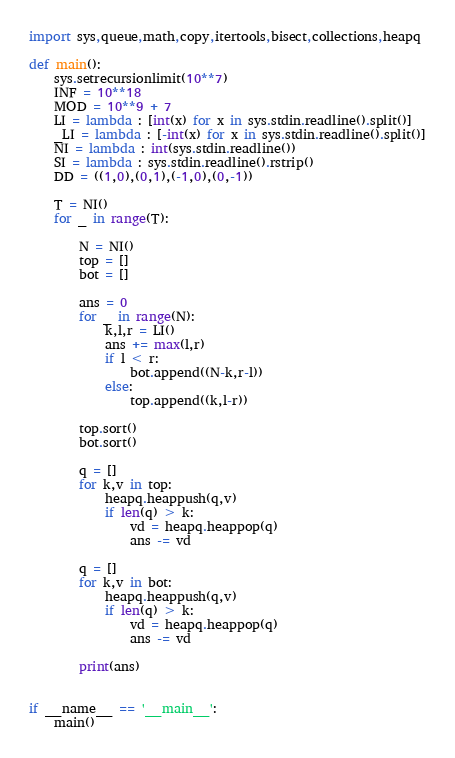<code> <loc_0><loc_0><loc_500><loc_500><_Python_>import sys,queue,math,copy,itertools,bisect,collections,heapq

def main():
    sys.setrecursionlimit(10**7)
    INF = 10**18
    MOD = 10**9 + 7
    LI = lambda : [int(x) for x in sys.stdin.readline().split()]
    _LI = lambda : [-int(x) for x in sys.stdin.readline().split()]
    NI = lambda : int(sys.stdin.readline())
    SI = lambda : sys.stdin.readline().rstrip()
    DD = ((1,0),(0,1),(-1,0),(0,-1))

    T = NI()
    for _ in range(T):

        N = NI()
        top = []
        bot = []

        ans = 0
        for _ in range(N):
            k,l,r = LI()
            ans += max(l,r)
            if l < r:
                bot.append((N-k,r-l))
            else:
                top.append((k,l-r))

        top.sort()
        bot.sort()

        q = []
        for k,v in top:
            heapq.heappush(q,v)
            if len(q) > k:
                vd = heapq.heappop(q)
                ans -= vd

        q = []
        for k,v in bot:
            heapq.heappush(q,v)
            if len(q) > k:
                vd = heapq.heappop(q)
                ans -= vd

        print(ans)


if __name__ == '__main__':
    main()</code> 